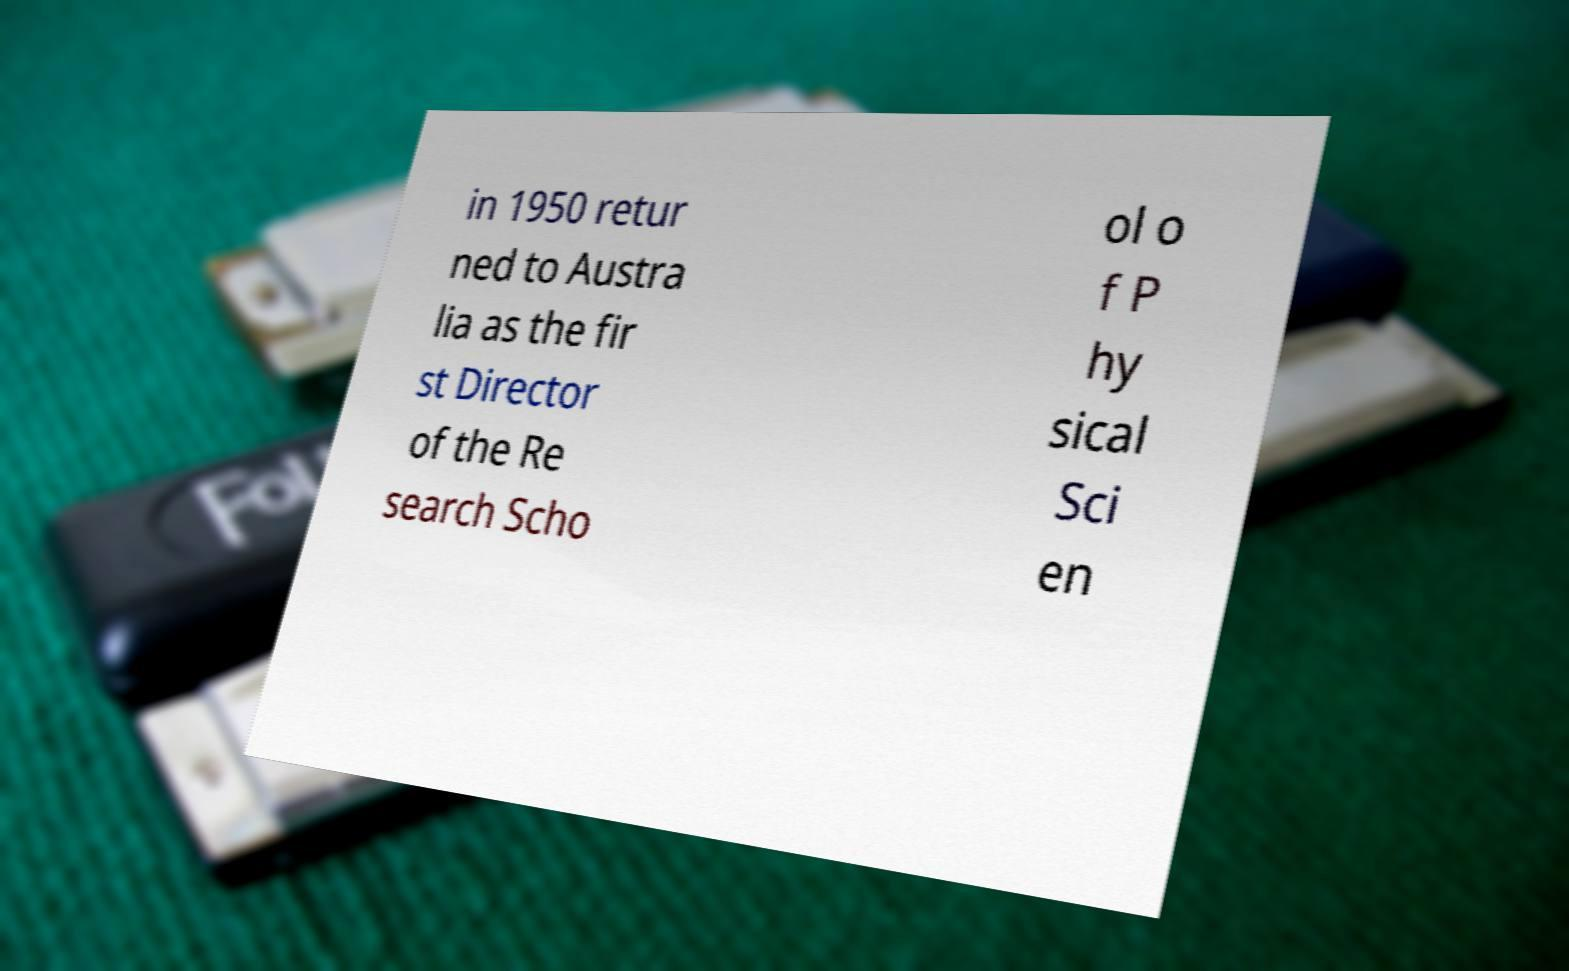Can you read and provide the text displayed in the image?This photo seems to have some interesting text. Can you extract and type it out for me? in 1950 retur ned to Austra lia as the fir st Director of the Re search Scho ol o f P hy sical Sci en 